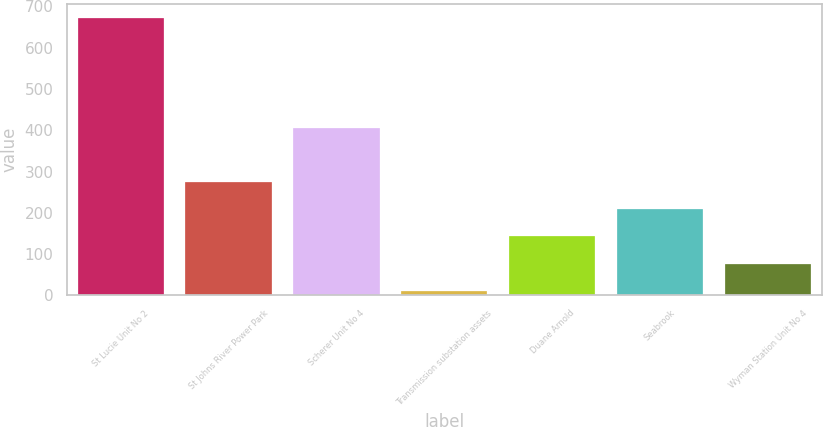Convert chart. <chart><loc_0><loc_0><loc_500><loc_500><bar_chart><fcel>St Lucie Unit No 2<fcel>St Johns River Power Park<fcel>Scherer Unit No 4<fcel>Transmission substation assets<fcel>Duane Arnold<fcel>Seabrook<fcel>Wyman Station Unit No 4<nl><fcel>672<fcel>275.4<fcel>405<fcel>11<fcel>143.2<fcel>209.3<fcel>77.1<nl></chart> 